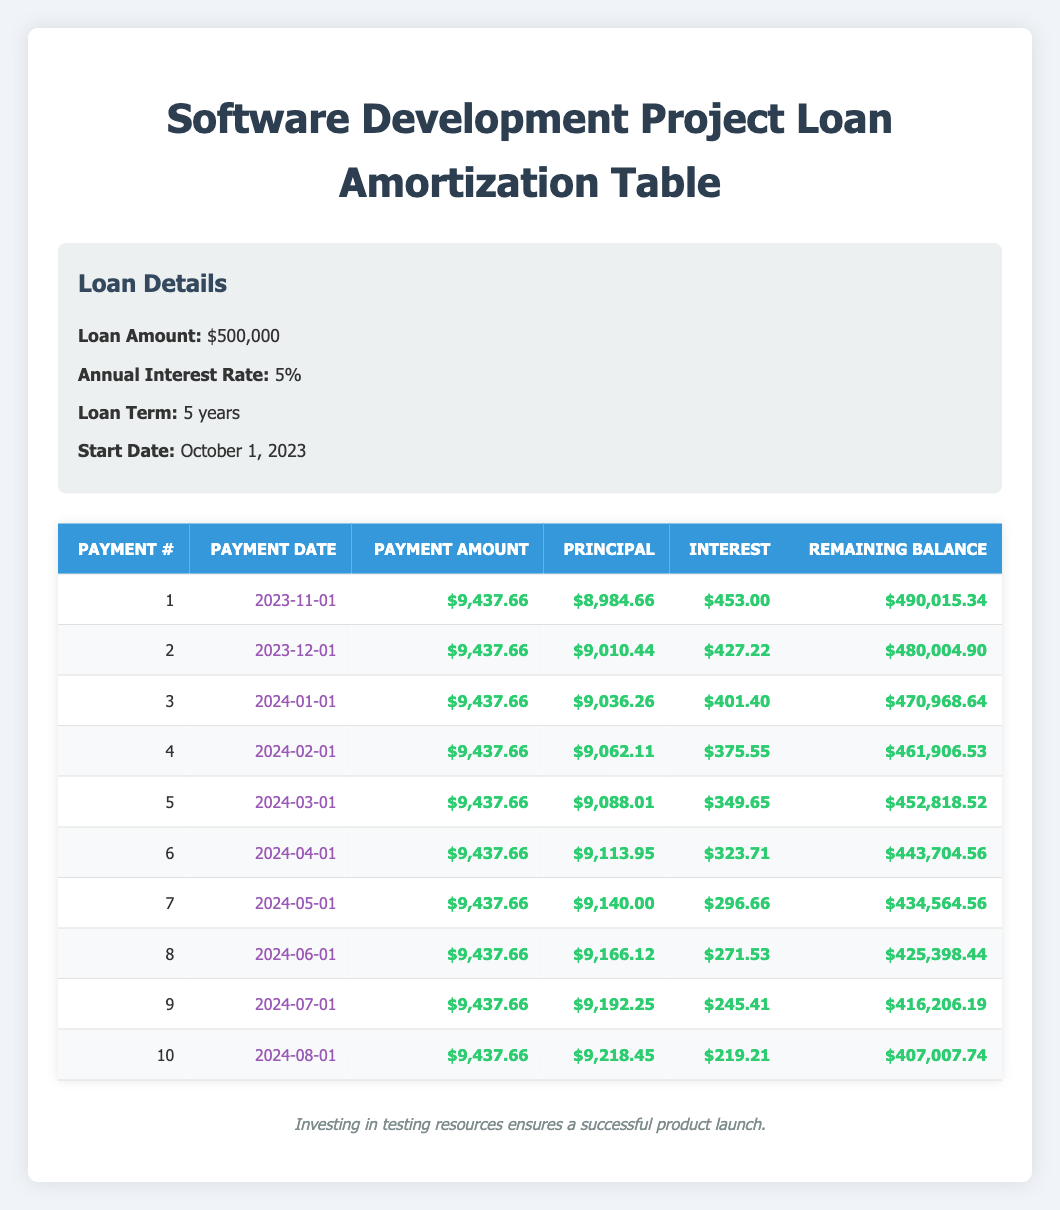What is the payment amount for the first installment? The first installment payment amount appears in the third column of the first row in the table, which shows $9,437.66.
Answer: $9,437.66 What is the principal amount paid in the second payment? The principal amount for the second payment is found in the fourth column of the second row, which is $9,010.44.
Answer: $9,010.44 Is the interest amount for the first payment greater than for the second payment? The interest for the first payment is $453.00 and for the second payment is $427.22. Since $453.00 is greater than $427.22, the statement is true.
Answer: Yes What is the remaining balance after the fifth payment? The remaining balance can be found in the last column of the fifth row, which shows $452,818.52 after making the fifth payment.
Answer: $452,818.52 What is the total amount paid in principal after the first three payments? To find the total principal for the first three payments, we sum $8,984.66 (first) + $9,010.44 (second) + $9,036.26 (third), which equals $26,031.36.
Answer: $26,031.36 What is the average remaining balance after the first 10 payments? The remaining balances after each of the 10 payments can be summed, and then divided by 10 to find the average. The total remaining balance is $490,015.34 + $480,004.90 + $470,968.64 + $461,906.53 + $452,818.52 + $443,704.56 + $434,564.56 + $425,398.44 + $416,206.19 + $407,007.74 = $4,448,853.10. Dividing by 10 gives an average remaining balance of $444,885.31.
Answer: $444,885.31 What is the difference between the principal amount of the first and the last payment? The principal amount of the first payment is $8,984.66 and for the tenth payment, it is $9,218.45. The difference is $9,218.45 - $8,984.66 = $233.79.
Answer: $233.79 Is the total interest paid in the first four payments greater than $1,500? The total interest for the first four payments is calculated by adding $453.00 + $427.22 + $401.40 + $375.55, which equals $1,657.17. Since $1,657.17 is greater than $1,500, the statement is true.
Answer: Yes What is the smallest principal amount paid in any of the first 10 payments? Looking through the principal amounts of the first 10 payments, the smallest is $8,984.66 from the first payment.
Answer: $8,984.66 